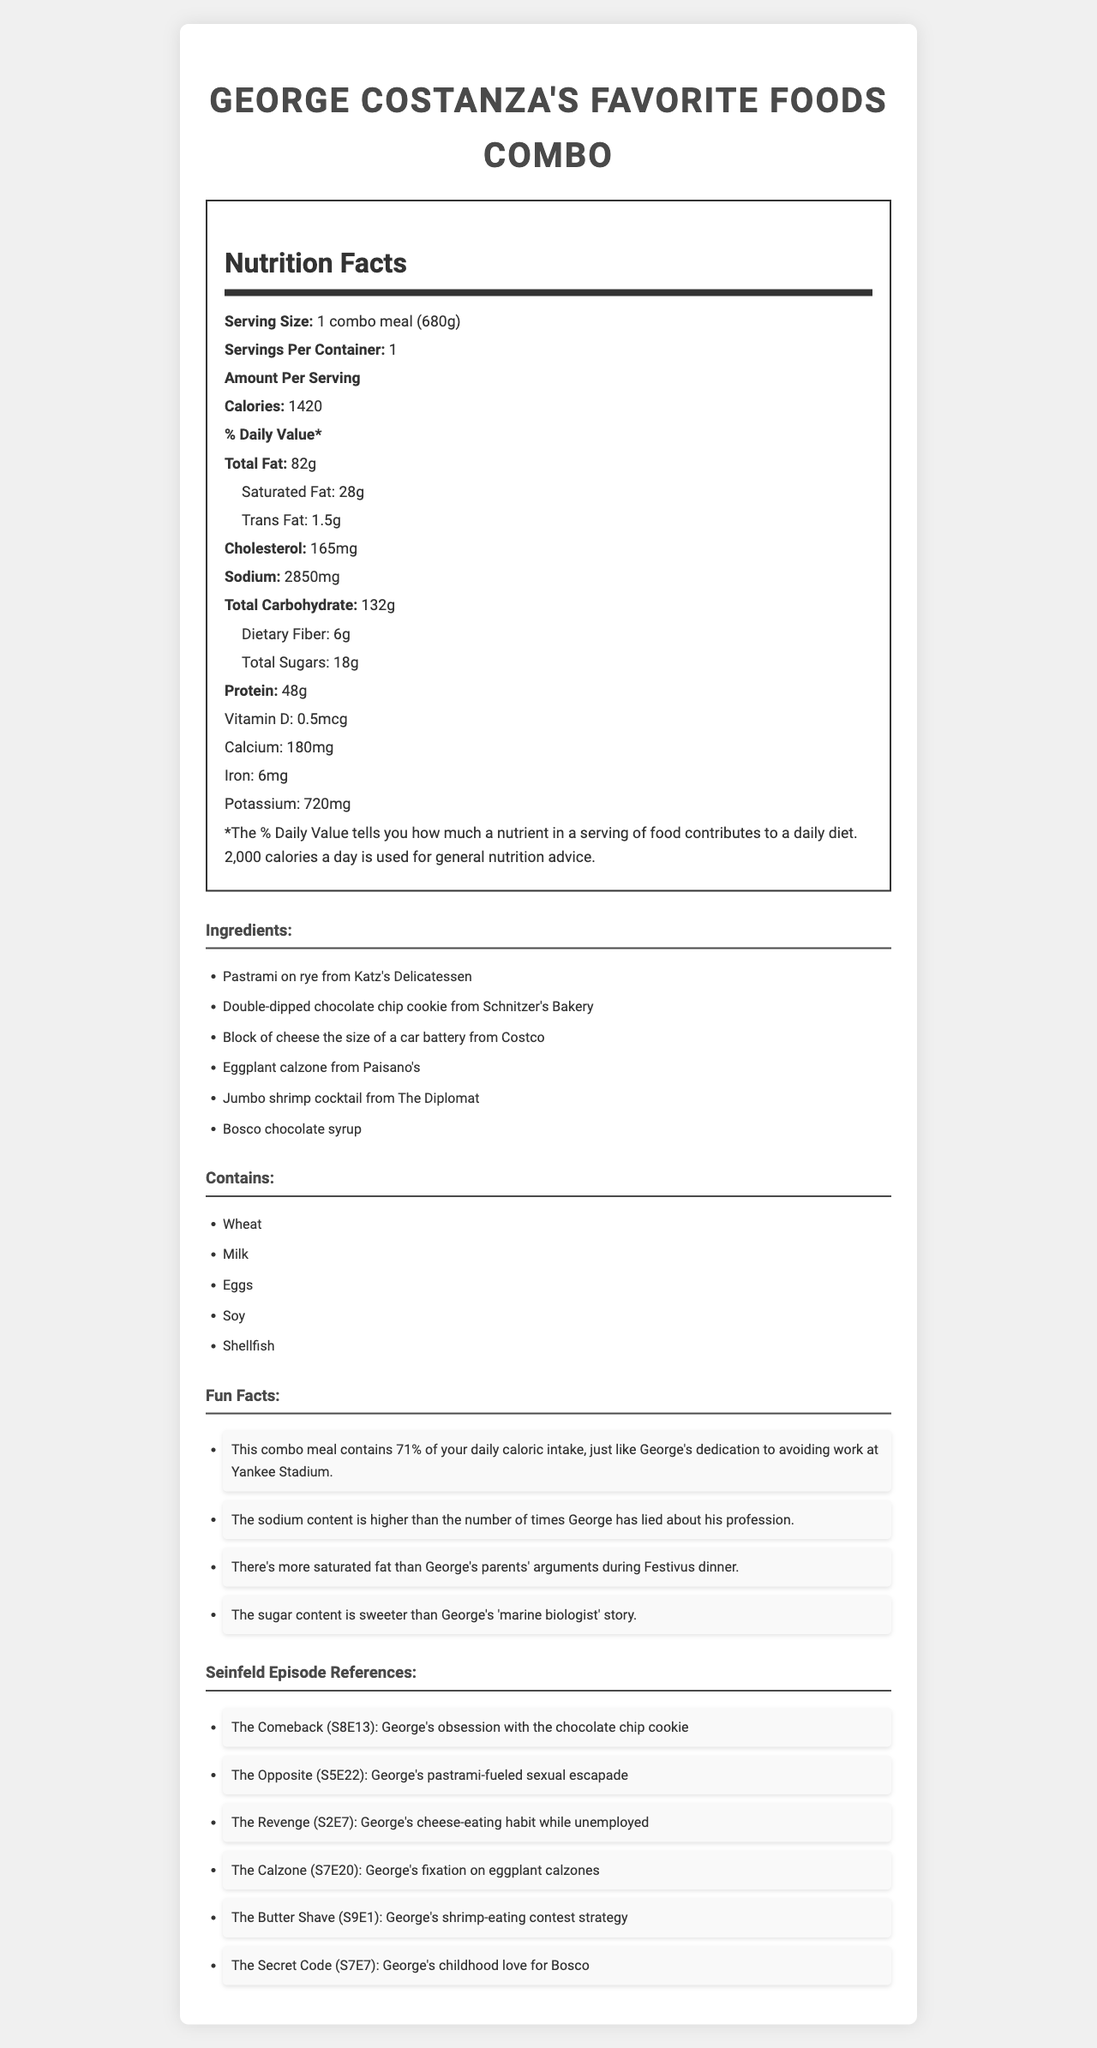what is the serving size of George Costanza's Favorite Foods Combo? The serving size is explicitly stated as "1 combo meal (680g)".
Answer: 1 combo meal (680g) how many calories are in a serving of George Costanza's Favorite Foods Combo? The nutrition facts label lists 1420 calories per serving.
Answer: 1420 what is the total fat content per serving? The total fat content is listed as 82g per serving.
Answer: 82g how much protein is in each serving? The protein content for each serving is 48g, as stated in the nutrition facts.
Answer: 48g which episode reference deals with George's fixation on eggplant calzones? The episode reference listed under "Seinfeld Episode References" for George's fixation on eggplant calzones is "The Calzone (S7E20)".
Answer: The Calzone (S7E20) what are the allergens present in George Costanza's Favorite Foods Combo? The document lists allergens as Wheat, Milk, Eggs, Soy, and Shellfish.
Answer: Wheat, Milk, Eggs, Soy, Shellfish how much sodium does the meal contain? The sodium content is 2850mg as per the nutrition facts label.
Answer: 2850mg is more than half of the daily caloric intake covered by this combo meal? (Yes/No) The fun facts section mentions that the combo covers 71% of the daily caloric intake, which is more than half.
Answer: Yes which of the following ingredients is not part of George Costanza's Favorite Foods Combo? A. Pastrami on rye B. Double-dipped chocolate chip cookie C. Tofu stir-fry Tofu stir-fry is not listed among the ingredients in the combo meal.
Answer: C what is the main idea of the document? The document details the calorie and nutrient content, lists ingredients, and highlights interesting facts and episode references about George Costanza's favorite foods.
Answer: The document provides the nutritional details, ingredient list, allergens, fun facts, and Seinfeld episode references related to George Costanza's Favorite Foods Combo. how many grams of dietary fiber are there per serving? The nutrition facts label specifies 6g of dietary fiber per serving.
Answer: 6g which episode reference includes George’s childhood love for Bosco? The document lists "The Secret Code (S7E7)" under Seinfeld Episode References in connection with George's love for Bosco.
Answer: The Secret Code (S7E7) how much cholesterol is in each serving? A. 145mg B. 185mg C. 165mg D. 125mg The document states that each serving contains 165mg of cholesterol.
Answer: C which nutrient has a value of 0.5mcg per serving? According to the nutrition facts label, Vitamin D is present in a quantity of 0.5mcg.
Answer: Vitamin D how many Seinfeld episode references are listed? There are 6 Seinfeld episode references listed in the document.
Answer: 6 compare the total carbohydrate and dietary fiber content. The nutrition facts specify 132g of total carbohydrates and 6g of dietary fiber.
Answer: Total carbohydrate content is 132g while dietary fiber is 6g. what is the calcium content in the meal? The calcium content is listed as 180mg in the nutrition facts.
Answer: 180mg how much saturated fat does this meal contain compared to the total fat? The nutrition facts label states that the meal contains 28g of saturated fat out of a total fat content of 82g.
Answer: 28g of saturated fat out of 82g total fat what is the exact amount of trans fat in each serving? The nutrition facts label indicates there are 1.5g of trans fat per serving.
Answer: 1.5g what episode features George’s obsession with the chocolate chip cookie? The episode reference "The Comeback (S8E13)" is connected to George’s obsession with the chocolate chip cookie.
Answer: The Comeback (S8E13) how many grams is one combo meal? The serving size is listed as "1 combo meal (680g)".
Answer: 680g how old was George when he first tried Bosco chocolate syrup? The document does not provide specific details about George's age when he first tried Bosco chocolate syrup.
Answer: Not enough information 